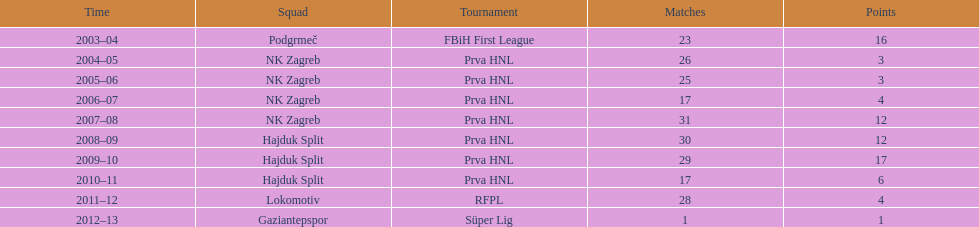Which team has scored the most goals? Hajduk Split. 